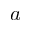Convert formula to latex. <formula><loc_0><loc_0><loc_500><loc_500>a</formula> 